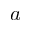Convert formula to latex. <formula><loc_0><loc_0><loc_500><loc_500>a</formula> 